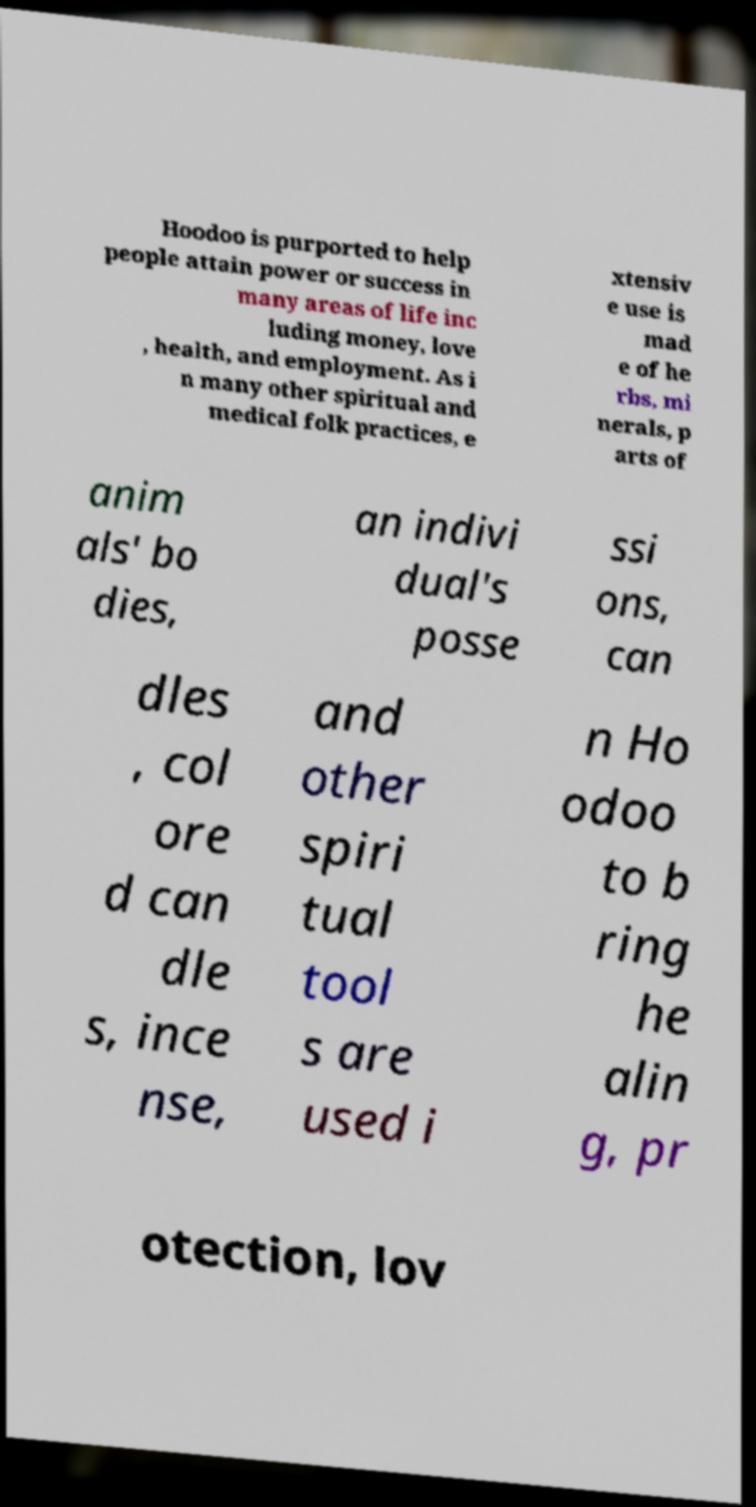There's text embedded in this image that I need extracted. Can you transcribe it verbatim? Hoodoo is purported to help people attain power or success in many areas of life inc luding money, love , health, and employment. As i n many other spiritual and medical folk practices, e xtensiv e use is mad e of he rbs, mi nerals, p arts of anim als' bo dies, an indivi dual's posse ssi ons, can dles , col ore d can dle s, ince nse, and other spiri tual tool s are used i n Ho odoo to b ring he alin g, pr otection, lov 